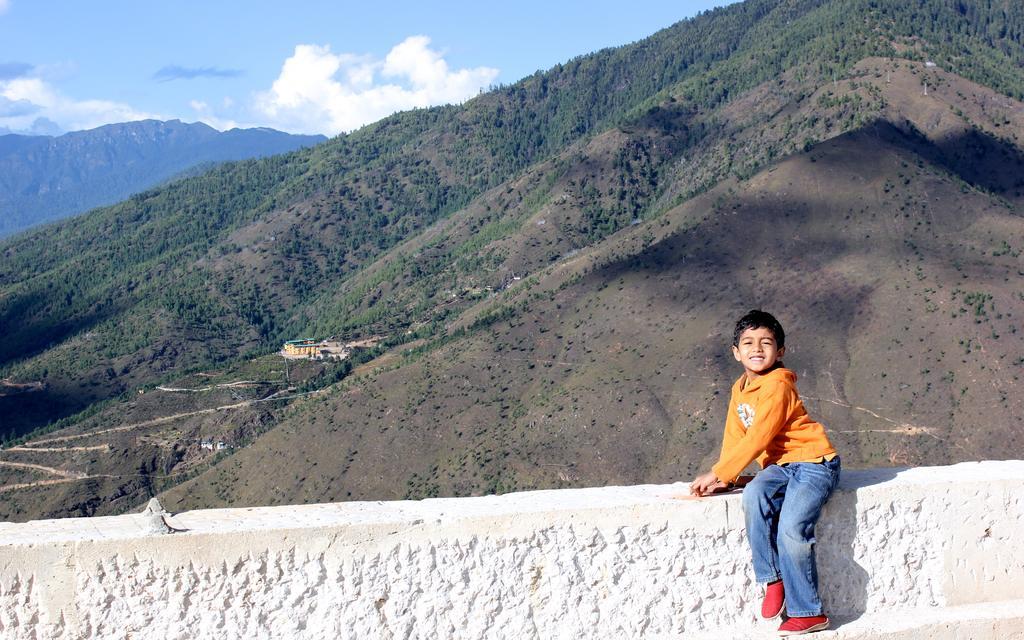Please provide a concise description of this image. In this image we can see a child wearing orange T-shirt and red color shoes is sitting on the wall. In the background, we can see the hills, we can see trees and the blue color sky with clouds. 